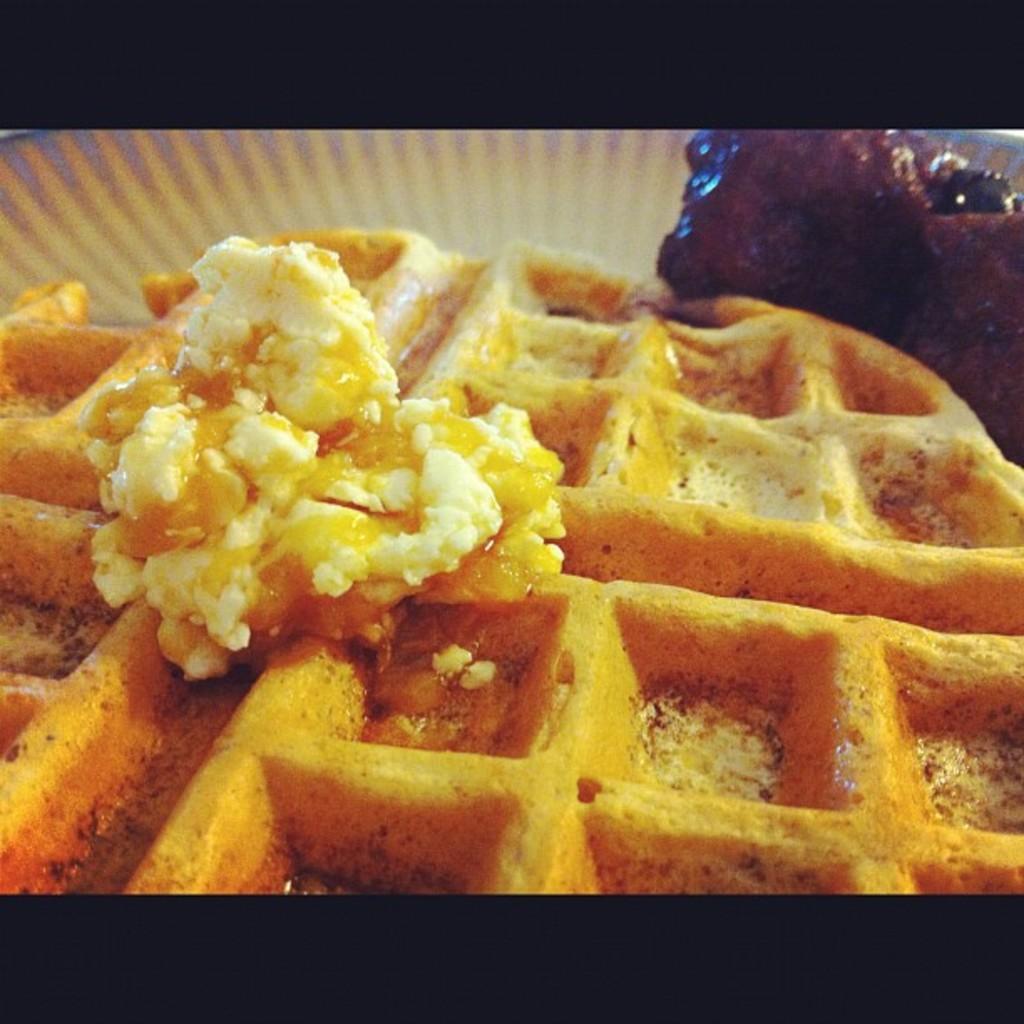In one or two sentences, can you explain what this image depicts? In this image we can see few food products placed on some object. 